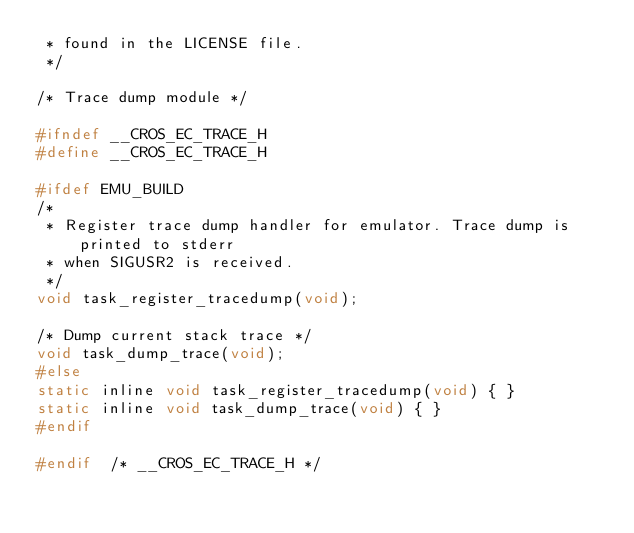Convert code to text. <code><loc_0><loc_0><loc_500><loc_500><_C_> * found in the LICENSE file.
 */

/* Trace dump module */

#ifndef __CROS_EC_TRACE_H
#define __CROS_EC_TRACE_H

#ifdef EMU_BUILD
/*
 * Register trace dump handler for emulator. Trace dump is printed to stderr
 * when SIGUSR2 is received.
 */
void task_register_tracedump(void);

/* Dump current stack trace */
void task_dump_trace(void);
#else
static inline void task_register_tracedump(void) { }
static inline void task_dump_trace(void) { }
#endif

#endif  /* __CROS_EC_TRACE_H */
</code> 